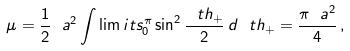<formula> <loc_0><loc_0><loc_500><loc_500>\mu = \frac { 1 } { 2 } \ a ^ { 2 } \int \lim i t s _ { 0 } ^ { \pi } \sin ^ { 2 } \frac { \ t h _ { + } } { 2 } \, d \ t h _ { + } = \frac { \pi \ a ^ { 2 } } { 4 } \, ,</formula> 